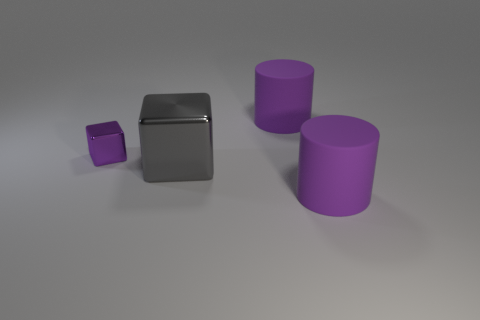How many purple matte things are the same size as the purple metallic thing?
Offer a very short reply. 0. What is the material of the large gray thing that is the same shape as the small metallic object?
Your answer should be compact. Metal. Do the cylinder that is in front of the small purple block and the rubber object behind the big gray thing have the same color?
Ensure brevity in your answer.  Yes. What shape is the gray shiny object that is in front of the purple metallic thing?
Provide a short and direct response. Cube. The small thing is what color?
Provide a short and direct response. Purple. There is a thing that is the same material as the small block; what is its shape?
Your answer should be compact. Cube. Do the purple thing in front of the gray cube and the large metallic thing have the same size?
Offer a terse response. Yes. What number of objects are either objects that are in front of the purple shiny block or large purple matte things behind the large shiny thing?
Provide a succinct answer. 3. There is a metal cube to the left of the gray cube; is it the same color as the big metallic block?
Your response must be concise. No. How many metallic objects are either gray cubes or small objects?
Your response must be concise. 2. 